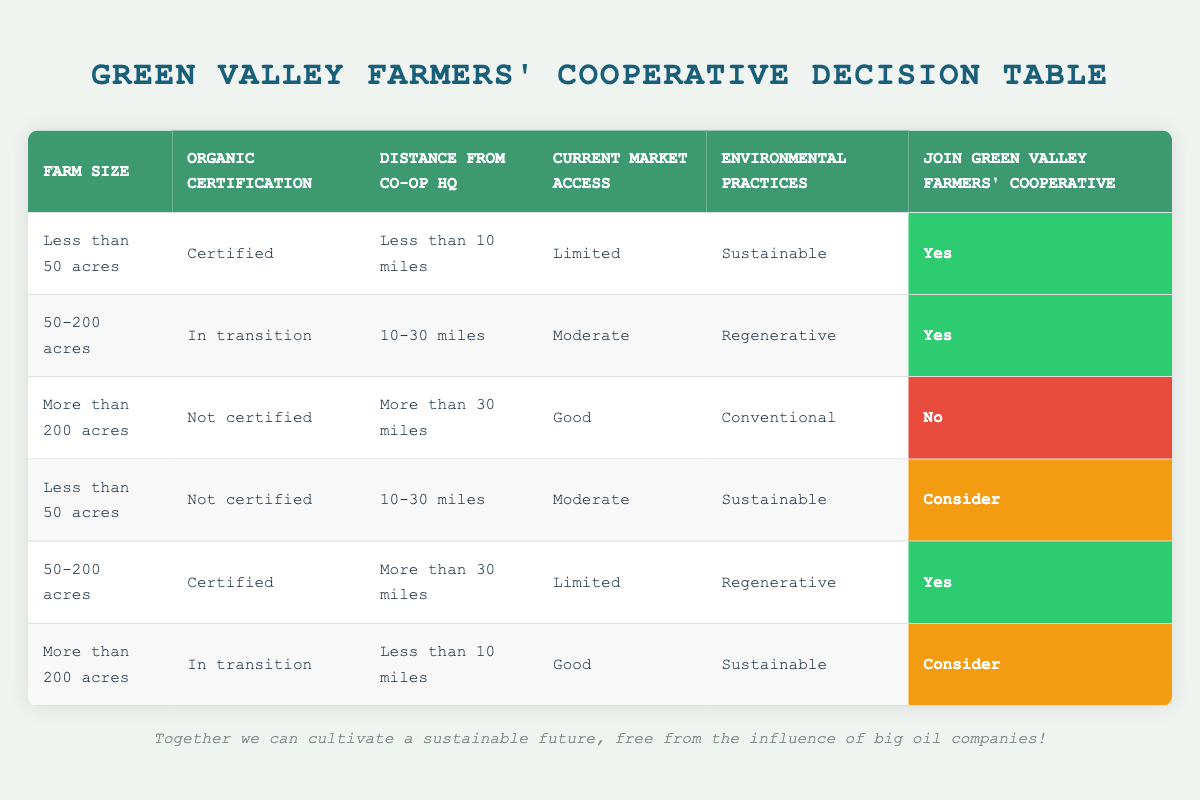What is the action advised for a farm of less than 50 acres that is certified, located less than 10 miles from the co-op headquarters, has limited market access, and follows sustainable practices? By examining the table, this specific condition matches the first row directly, which indicates that the action is to join the cooperative.
Answer: Yes What happens if a farm of more than 200 acres is not certified and has good market access? This scenario matches the third row in the table, where the action indicated is to not join the cooperative.
Answer: No How many farms of size 50-200 acres with organic certification are advised to join the cooperative? There are two rows that meet this criterion: the second row (In transition, 10-30 miles, Moderate, Regenerative) and the fifth row (Certified, more than 30 miles, Limited, Regenerative). However, only the fifth row suggests joining, so there is one instance.
Answer: 1 For a farm that is in transition and located less than 10 miles from the co-op headquarters, what is a possible action? The sixth row defines this condition and suggests a consideration for joining the cooperative. No clear decision to join or not is provided in this case, indicating that further evaluation is needed.
Answer: Consider What are the possible actions for farms that are more than 200 acres? When referring to the third and sixth rows, the actions indicated are "No" and "Consider" respectively. Thus, there are two possible actions: one suggests not joining, while the other recommends consideration.
Answer: No, Consider If a farm is more than 200 acres, has sustainable practices, not certified, and is located more than 30 miles from the cooperative, what action applies? This matches the third row's condition related to both size and certification status, where the action suggests not joining the cooperative.
Answer: No How many total entries suggest joining the cooperative? By reviewing the table, a count of “Yes” responses in the action column shows three instances across all rows. Thus, there are three entries that propose joining.
Answer: 3 What are the environmental practices of the farms that are advised to consider joining the cooperative? Looking at the table, the farms that are considered for joining are indicated in the fourth (Sustainable) and the sixth row (Sustainable), which both have sustainable practices listed.
Answer: Sustainable 